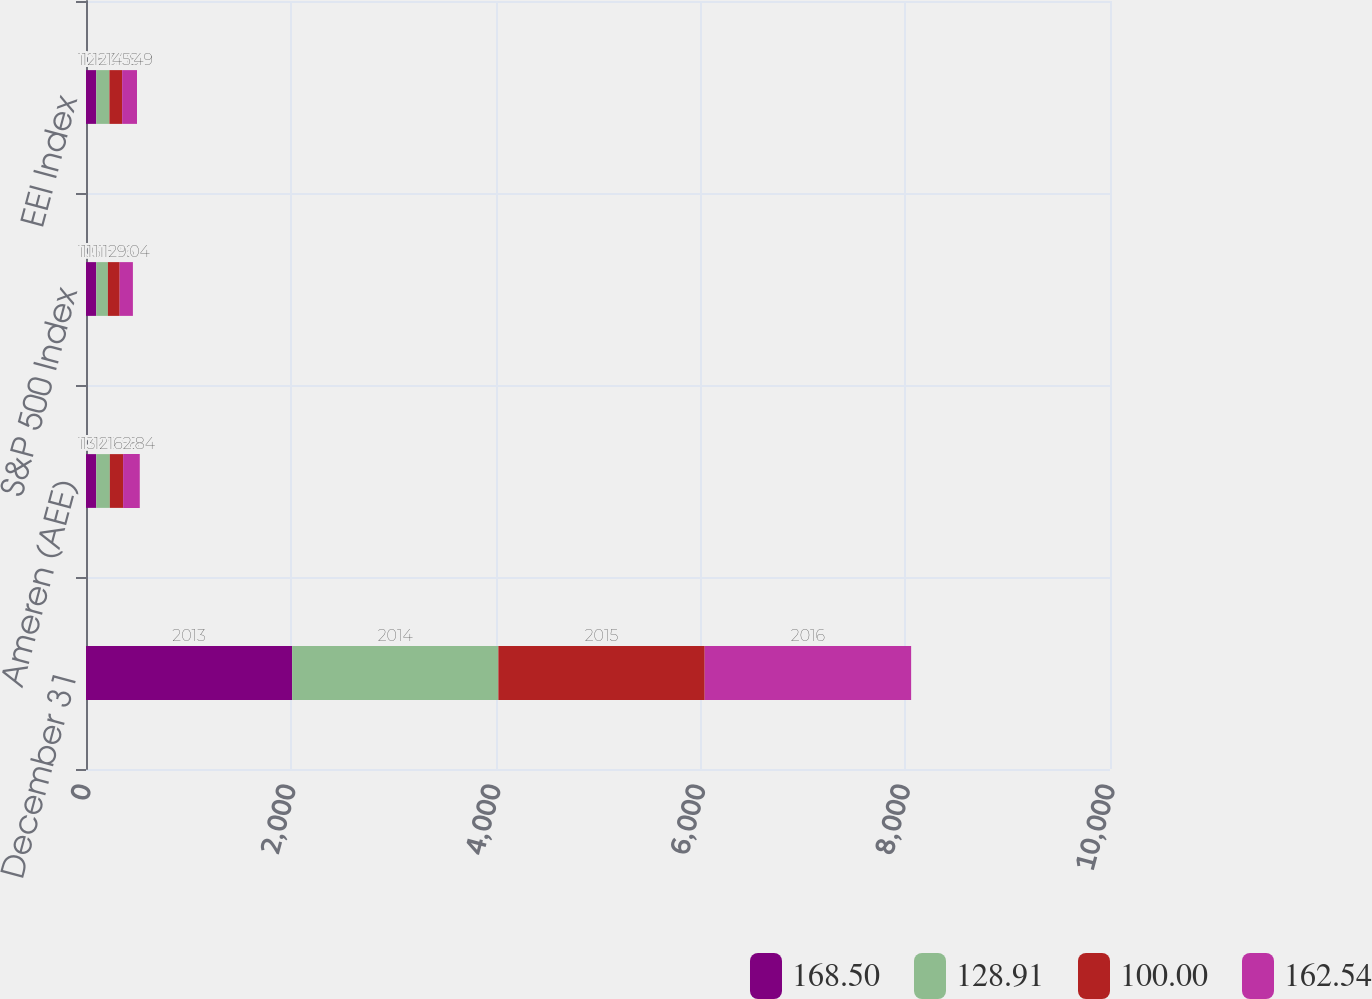Convert chart to OTSL. <chart><loc_0><loc_0><loc_500><loc_500><stacked_bar_chart><ecel><fcel>December 31<fcel>Ameren (AEE)<fcel>S&P 500 Index<fcel>EEI Index<nl><fcel>168.5<fcel>2013<fcel>100<fcel>100<fcel>100<nl><fcel>128.91<fcel>2014<fcel>132.73<fcel>113.69<fcel>128.91<nl><fcel>100<fcel>2015<fcel>129.58<fcel>115.26<fcel>123.88<nl><fcel>162.54<fcel>2016<fcel>162.84<fcel>129.04<fcel>145.49<nl></chart> 